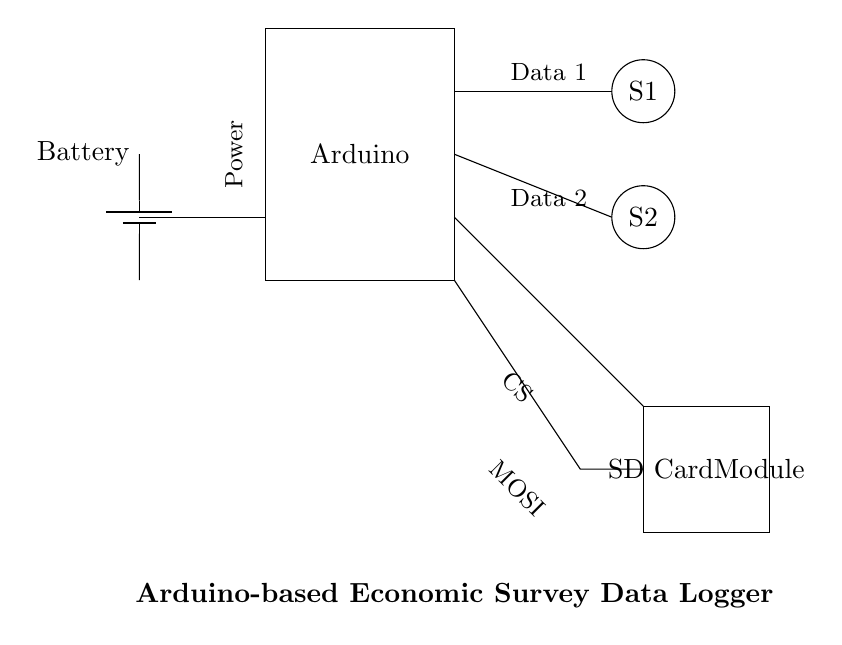What is the main component of this circuit? The main component is the Arduino, which processes the data collected from the sensors.
Answer: Arduino How many sensors are present in the circuit? The circuit has two sensors, labeled S1 and S2, representing their role in data collection.
Answer: 2 What does the SD card module do in this circuit? The SD card module stores the data collected from the sensors for later retrieval and analysis.
Answer: Data storage What is the function of the battery in this circuit? The battery provides the necessary power to operate the Arduino and the connected components.
Answer: Power supply Which connections indicate data transmission from the sensors to the Arduino? The lines connecting S1 and S2 to the Arduino indicate where data is transmitted for processing.
Answer: Data lines Why is an SD card module used instead of internal memory? An SD card provides larger storage capacity, enabling the collection of more extensive survey data without limitations.
Answer: Larger storage capacity 